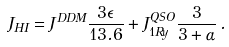<formula> <loc_0><loc_0><loc_500><loc_500>J _ { H I } = J ^ { D D M } \frac { 3 \epsilon } { 1 3 . 6 } + J _ { 1 R y } ^ { Q S O } \frac { 3 } { 3 + \alpha } \, .</formula> 